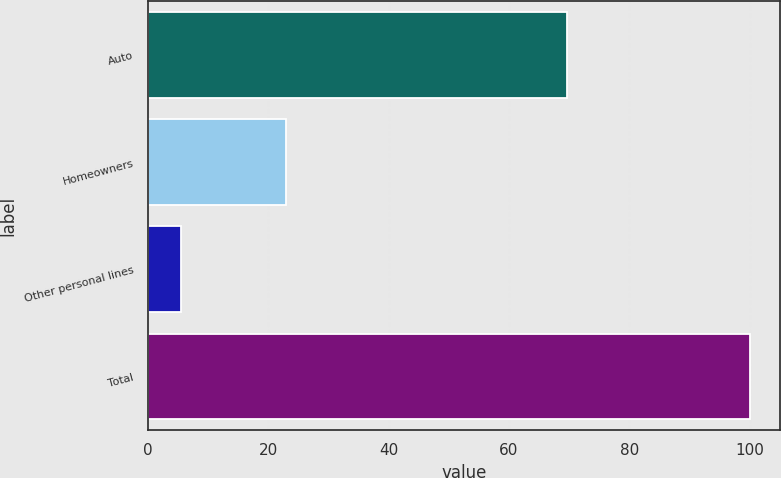Convert chart to OTSL. <chart><loc_0><loc_0><loc_500><loc_500><bar_chart><fcel>Auto<fcel>Homeowners<fcel>Other personal lines<fcel>Total<nl><fcel>69.6<fcel>22.9<fcel>5.5<fcel>100<nl></chart> 